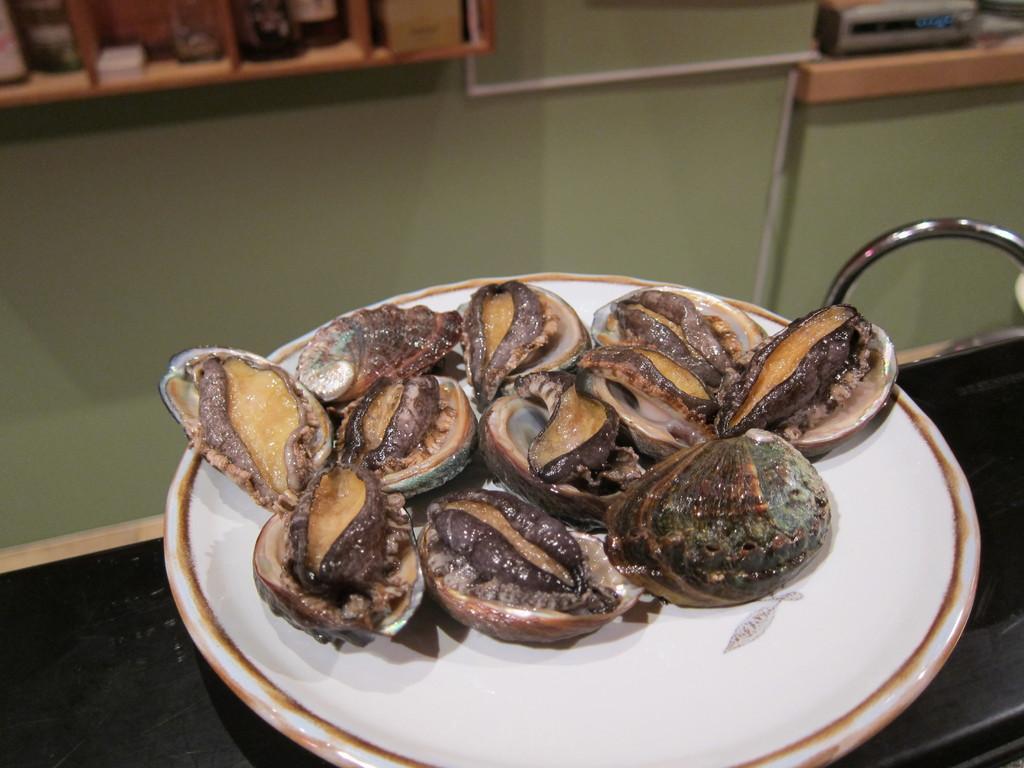Can you describe this image briefly? In this image we can see food item in a plate which is placed on a surface. Behind the plate we can see a wall and few objects placed on the shelf. 